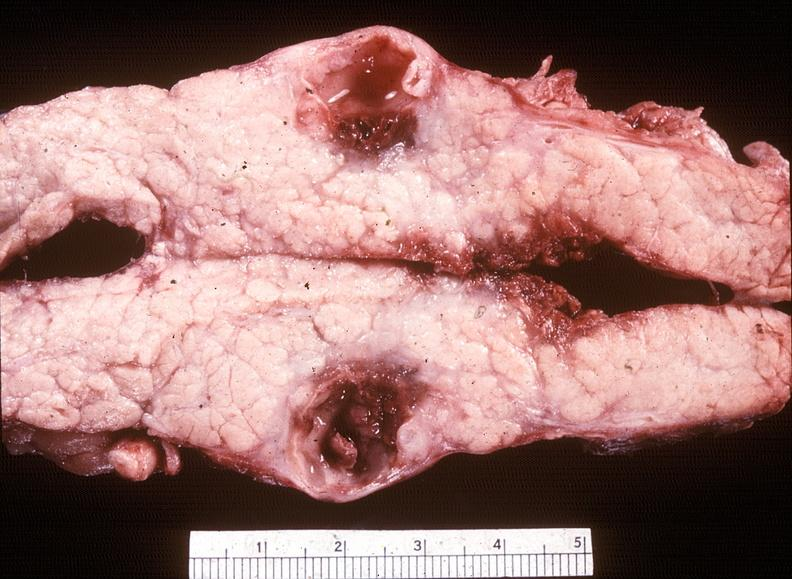does basal skull fracture show chronic pancreatitis with cyst formation?
Answer the question using a single word or phrase. No 